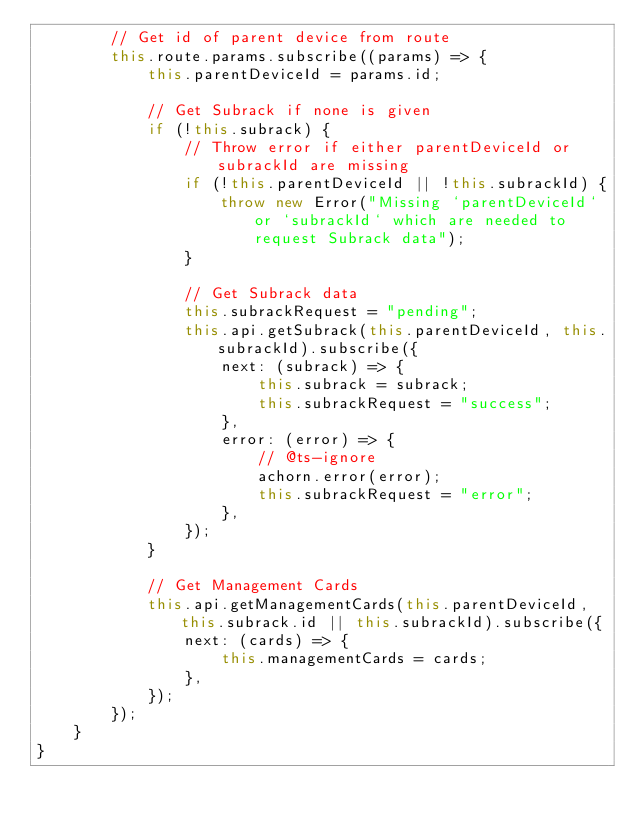<code> <loc_0><loc_0><loc_500><loc_500><_TypeScript_>        // Get id of parent device from route
        this.route.params.subscribe((params) => {
            this.parentDeviceId = params.id;

            // Get Subrack if none is given
            if (!this.subrack) {
                // Throw error if either parentDeviceId or subrackId are missing
                if (!this.parentDeviceId || !this.subrackId) {
                    throw new Error("Missing `parentDeviceId` or `subrackId` which are needed to request Subrack data");
                }

                // Get Subrack data
                this.subrackRequest = "pending";
                this.api.getSubrack(this.parentDeviceId, this.subrackId).subscribe({
                    next: (subrack) => {
                        this.subrack = subrack;
                        this.subrackRequest = "success";
                    },
                    error: (error) => {
                        // @ts-ignore
                        achorn.error(error);
                        this.subrackRequest = "error";
                    },
                });
            }

            // Get Management Cards
            this.api.getManagementCards(this.parentDeviceId, this.subrack.id || this.subrackId).subscribe({
                next: (cards) => {
                    this.managementCards = cards;
                },
            });
        });
    }
}
</code> 